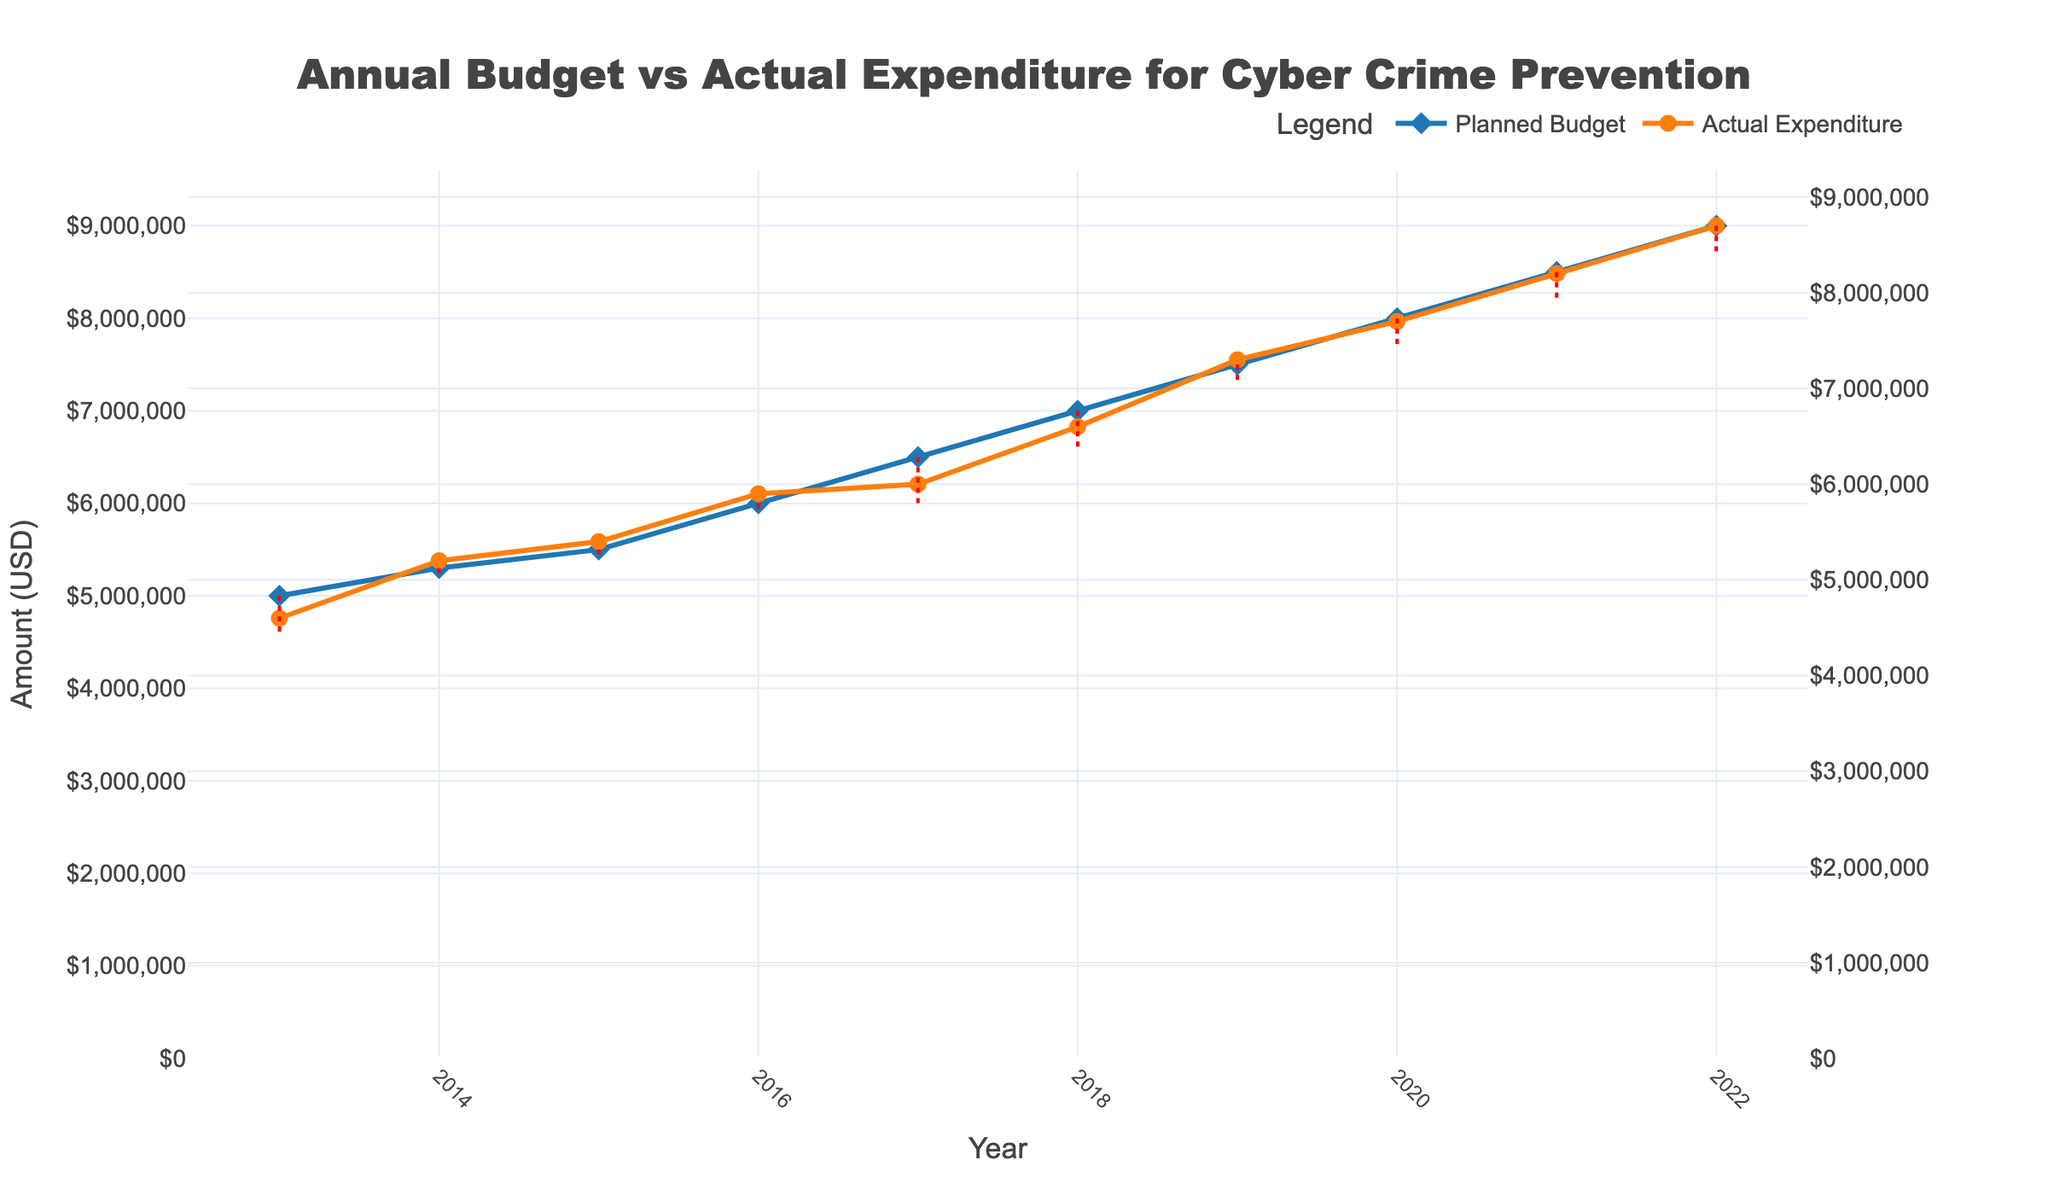what’s the title of the plot? The title is usually located at the top of the figure and provides a brief description of the plot. Here, it reads "Annual Budget vs Actual Expenditure for Cyber Crime Prevention."
Answer: Annual Budget vs Actual Expenditure for Cyber Crime Prevention How many data points are plotted for the Planned Budget? The x-axis represents the years from 2013 to 2022. Each year has one data point for the Planned Budget. Counting these points gives us 10 data points.
Answer: 10 In which year did the Actual Expenditure come closest to the Planned Budget? By examining the vertical distance between the two lines, the smallest gap can be observed for the year 2014, where the lines are almost overlapping.
Answer: 2014 What is the Planned Budget for 2017 and how does it compare to the Actual Expenditure in the same year? The Planned Budget for 2017 is $6,500,000, whereas the Actual Expenditure is $6,000,000. The Actual Expenditure was $500,000 less than the Planned Budget.
Answer: $500,000 less What is the trend of both Planned Budget and Actual Expenditure over the 10 years? Both the Planned Budget and Actual Expenditure show a consistent upward trend from 2013 to 2022. The amounts increase annually in a roughly steady manner.
Answer: Upward trend By how much did the Actual Expenditure increase from 2013 to 2022? The Actual Expenditure in 2013 was $4,600,000 and increased to $8,700,000 in 2022. The increase is $8,700,000 - $4,600,000 = $4,100,000.
Answer: $4,100,000 In which year was the discrepancy between Planned Budget and Actual Expenditure the greatest? How much was it? The largest discrepancy is seen in 2017 where the Planned Budget was $6,500,000 and the Actual Expenditure was $6,000,000. The discrepancy is $500,000.
Answer: 2017, $500,000 What is the average Planned Budget over the 10 years? Adding up all the Planned Budget values from 2013 to 2022 and then dividing by the number of years (10), we get (5000000 + 5300000 + 5500000 + 6000000 + 6500000 + 7000000 + 7500000 + 8000000 + 8500000 + 9000000) / 10 = $6830000.
Answer: $6,830,000 